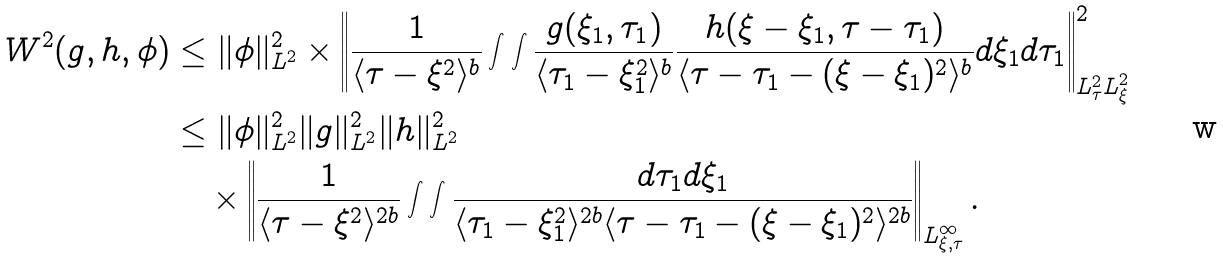<formula> <loc_0><loc_0><loc_500><loc_500>W ^ { 2 } ( g , h , \phi ) & \leq \| \phi \| _ { L ^ { 2 } } ^ { 2 } \times \left \| \frac { 1 } { \langle \tau - \xi ^ { 2 } \rangle ^ { b } } \int \int \frac { g ( \xi _ { 1 } , \tau _ { 1 } ) } { \langle \tau _ { 1 } - \xi _ { 1 } ^ { 2 } \rangle ^ { b } } \frac { h ( \xi - \xi _ { 1 } , \tau - \tau _ { 1 } ) } { \langle \tau - \tau _ { 1 } - ( \xi - \xi _ { 1 } ) ^ { 2 } \rangle ^ { b } } d \xi _ { 1 } d \tau _ { 1 } \right \| _ { L _ { \tau } ^ { 2 } L _ { \xi } ^ { 2 } } ^ { 2 } \\ & \leq \| \phi \| _ { L ^ { 2 } } ^ { 2 } \| g \| _ { L ^ { 2 } } ^ { 2 } \| h \| _ { L ^ { 2 } } ^ { 2 } \\ & \quad \times \left \| \frac { 1 } { \langle \tau - \xi ^ { 2 } \rangle ^ { 2 b } } \int \int \frac { d \tau _ { 1 } d \xi _ { 1 } } { \langle \tau _ { 1 } - \xi _ { 1 } ^ { 2 } \rangle ^ { 2 b } \langle \tau - \tau _ { 1 } - ( \xi - \xi _ { 1 } ) ^ { 2 } \rangle ^ { 2 b } } \right \| _ { L ^ { \infty } _ { \xi , \tau } } .</formula> 